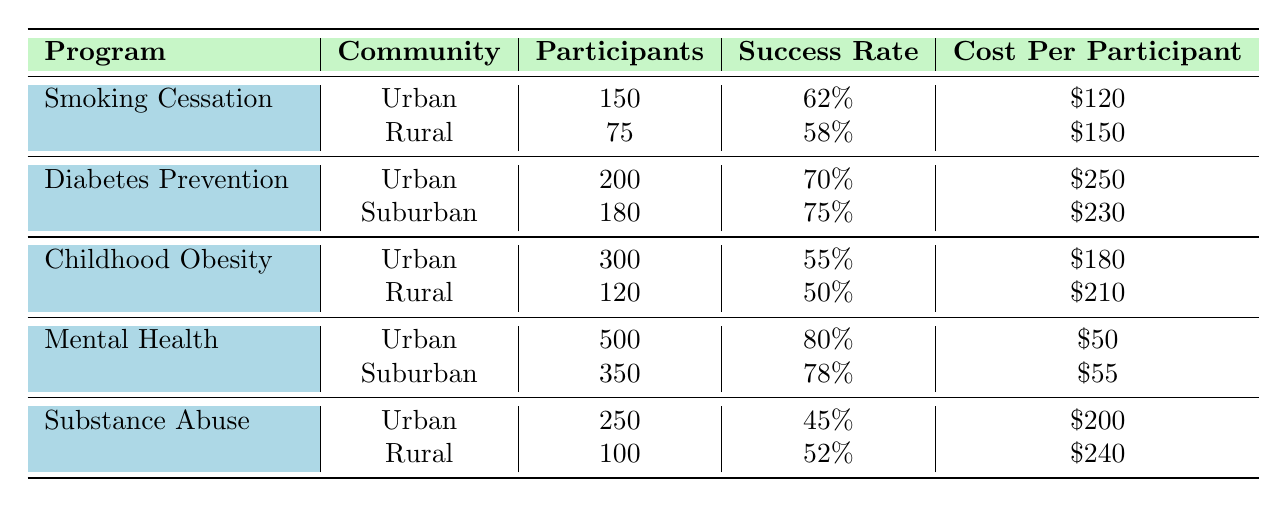What is the total number of participants in the Smoking Cessation Workshop conducted in Urban and Rural communities? The total number of participants in the Smoking Cessation Workshop is the sum of the Urban participants (150) and Rural participants (75), which is 150 + 75 = 225.
Answer: 225 Which public health program has the highest success rate in the Urban community? In the table, the Mental Health Awareness Campaign has a success rate of 80%, which is higher than the other programs listed for the Urban community (Smoking Cessation Workshop at 62%, Diabetes Prevention Program at 70%, Childhood Obesity Intervention at 55%, and Substance Abuse Prevention at 45%).
Answer: Mental Health Awareness Campaign Is the completion rate of the Diabetes Prevention Program higher in the Suburban community compared to the Urban community? The completion rate for the Diabetes Prevention Program is 90% in the Suburban community and 85% in the Urban community. Since 90% is greater than 85%, the Suburban community has a higher completion rate.
Answer: Yes What is the average cost per participant for the Childhood Obesity Intervention in both communities? The cost per participant for the Childhood Obesity Intervention is $180 in Urban and $210 in Rural. To find the average, add them together: 180 + 210 = 390, then divide by 2 to get 390 / 2 = 195.
Answer: 195 Which program had the lowest success rate across all communities, and what was that rate? The program with the lowest success rate is the Substance Abuse Prevention in the Urban community, with a success rate of 45%. This can be determined by comparing the success rates for each program in all communities listed in the table.
Answer: Substance Abuse Prevention, 45% 